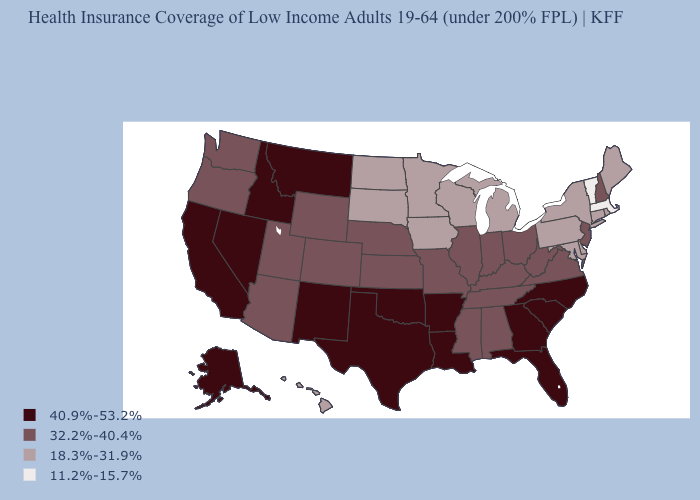What is the value of Florida?
Answer briefly. 40.9%-53.2%. Which states have the lowest value in the West?
Answer briefly. Hawaii. Name the states that have a value in the range 11.2%-15.7%?
Be succinct. Massachusetts, Vermont. Among the states that border Virginia , which have the highest value?
Write a very short answer. North Carolina. What is the value of Washington?
Short answer required. 32.2%-40.4%. Name the states that have a value in the range 18.3%-31.9%?
Concise answer only. Connecticut, Delaware, Hawaii, Iowa, Maine, Maryland, Michigan, Minnesota, New York, North Dakota, Pennsylvania, Rhode Island, South Dakota, Wisconsin. Does the first symbol in the legend represent the smallest category?
Short answer required. No. Which states have the lowest value in the South?
Write a very short answer. Delaware, Maryland. Name the states that have a value in the range 32.2%-40.4%?
Be succinct. Alabama, Arizona, Colorado, Illinois, Indiana, Kansas, Kentucky, Mississippi, Missouri, Nebraska, New Hampshire, New Jersey, Ohio, Oregon, Tennessee, Utah, Virginia, Washington, West Virginia, Wyoming. Name the states that have a value in the range 32.2%-40.4%?
Write a very short answer. Alabama, Arizona, Colorado, Illinois, Indiana, Kansas, Kentucky, Mississippi, Missouri, Nebraska, New Hampshire, New Jersey, Ohio, Oregon, Tennessee, Utah, Virginia, Washington, West Virginia, Wyoming. Name the states that have a value in the range 11.2%-15.7%?
Write a very short answer. Massachusetts, Vermont. What is the lowest value in states that border New Jersey?
Short answer required. 18.3%-31.9%. Name the states that have a value in the range 18.3%-31.9%?
Quick response, please. Connecticut, Delaware, Hawaii, Iowa, Maine, Maryland, Michigan, Minnesota, New York, North Dakota, Pennsylvania, Rhode Island, South Dakota, Wisconsin. Name the states that have a value in the range 40.9%-53.2%?
Write a very short answer. Alaska, Arkansas, California, Florida, Georgia, Idaho, Louisiana, Montana, Nevada, New Mexico, North Carolina, Oklahoma, South Carolina, Texas. Does the map have missing data?
Write a very short answer. No. 